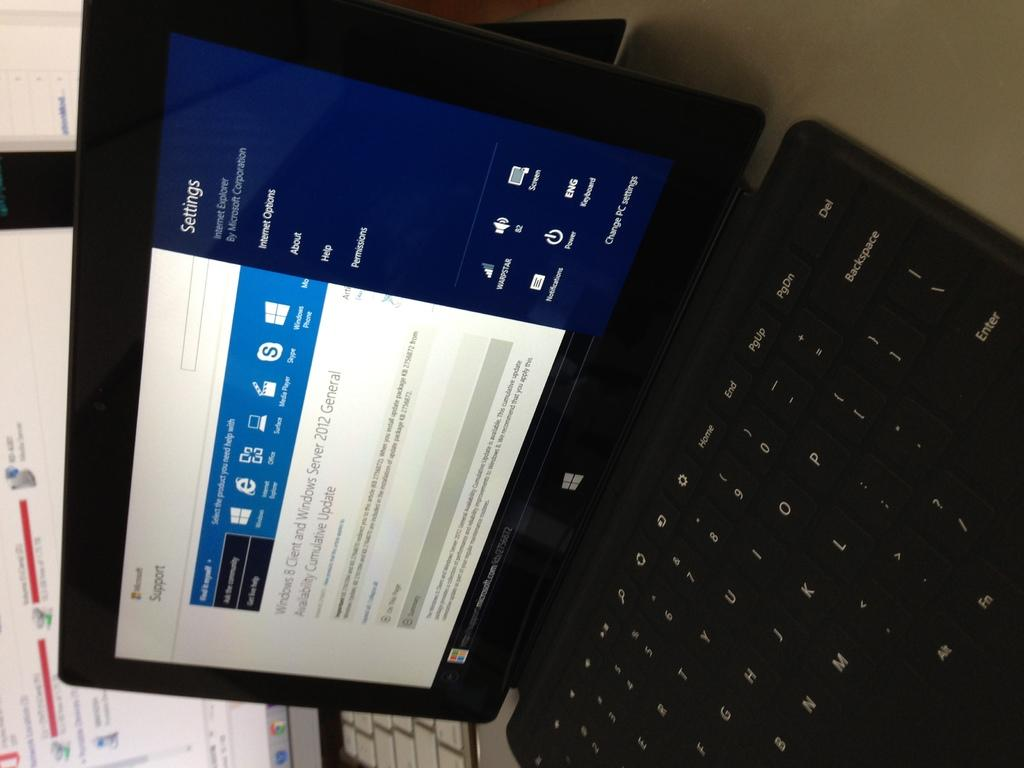What type of electronic devices are present in the image? There are laptops in the image. What can be seen on the laptop screens? Text and logos are visible on the laptop screens. What type of cheese is being used as a scene prop in the image? There is no cheese or scene prop present in the image. 